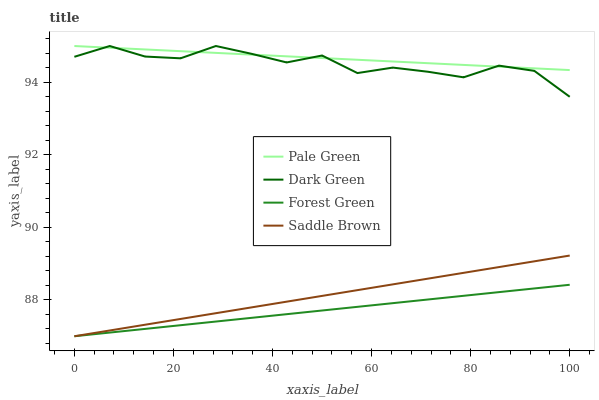Does Saddle Brown have the minimum area under the curve?
Answer yes or no. No. Does Saddle Brown have the maximum area under the curve?
Answer yes or no. No. Is Pale Green the smoothest?
Answer yes or no. No. Is Pale Green the roughest?
Answer yes or no. No. Does Pale Green have the lowest value?
Answer yes or no. No. Does Saddle Brown have the highest value?
Answer yes or no. No. Is Forest Green less than Pale Green?
Answer yes or no. Yes. Is Pale Green greater than Saddle Brown?
Answer yes or no. Yes. Does Forest Green intersect Pale Green?
Answer yes or no. No. 